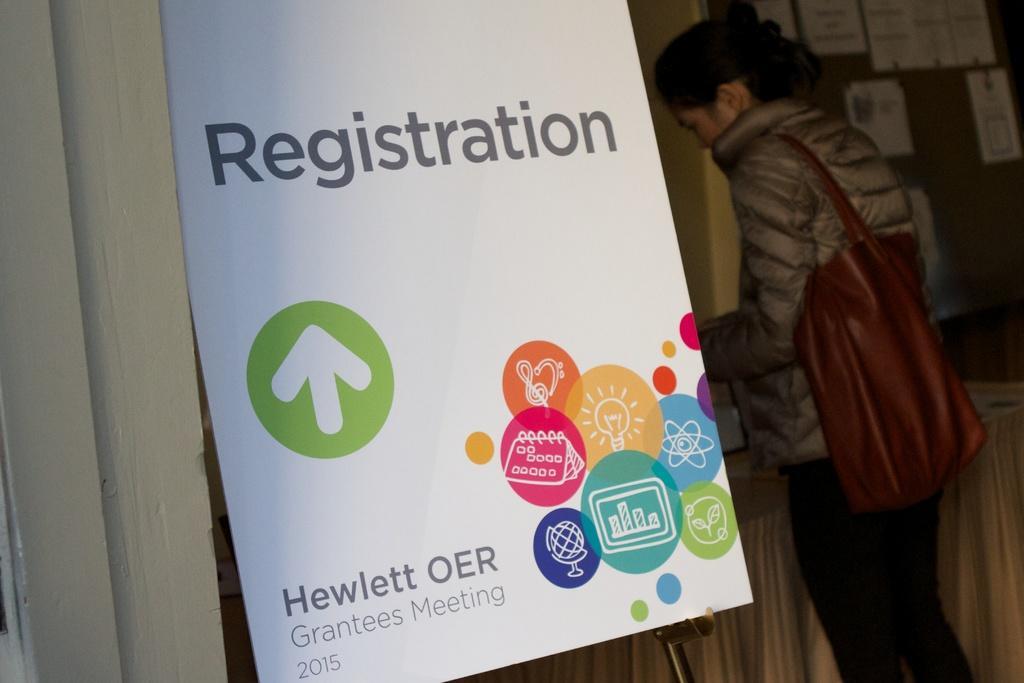Describe this image in one or two sentences. In the foreground of the picture there are a board. On the left there is door. On the right there is a woman standing, wearing and handbag. In the background there is a notice board, on the board there are papers stocked. 